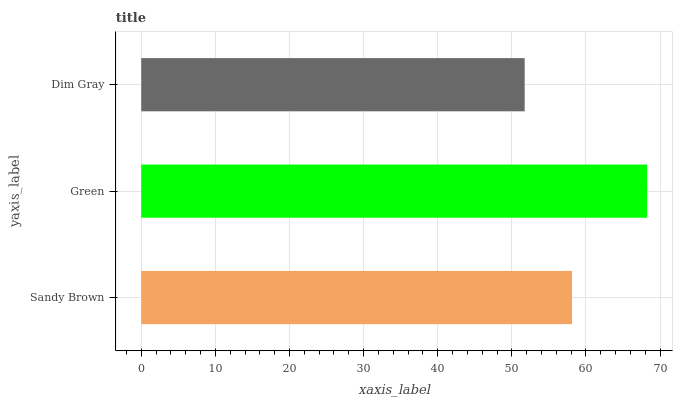Is Dim Gray the minimum?
Answer yes or no. Yes. Is Green the maximum?
Answer yes or no. Yes. Is Green the minimum?
Answer yes or no. No. Is Dim Gray the maximum?
Answer yes or no. No. Is Green greater than Dim Gray?
Answer yes or no. Yes. Is Dim Gray less than Green?
Answer yes or no. Yes. Is Dim Gray greater than Green?
Answer yes or no. No. Is Green less than Dim Gray?
Answer yes or no. No. Is Sandy Brown the high median?
Answer yes or no. Yes. Is Sandy Brown the low median?
Answer yes or no. Yes. Is Dim Gray the high median?
Answer yes or no. No. Is Green the low median?
Answer yes or no. No. 